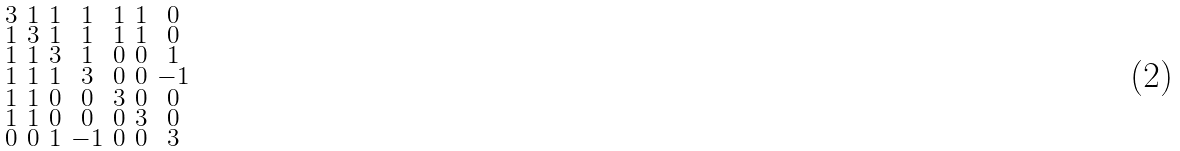<formula> <loc_0><loc_0><loc_500><loc_500>\begin{smallmatrix} 3 & 1 & 1 & 1 & 1 & 1 & 0 \\ 1 & 3 & 1 & 1 & 1 & 1 & 0 \\ 1 & 1 & 3 & 1 & 0 & 0 & 1 \\ 1 & 1 & 1 & 3 & 0 & 0 & - 1 \\ 1 & 1 & 0 & 0 & 3 & 0 & 0 \\ 1 & 1 & 0 & 0 & 0 & 3 & 0 \\ 0 & 0 & 1 & - 1 & 0 & 0 & 3 \end{smallmatrix}</formula> 